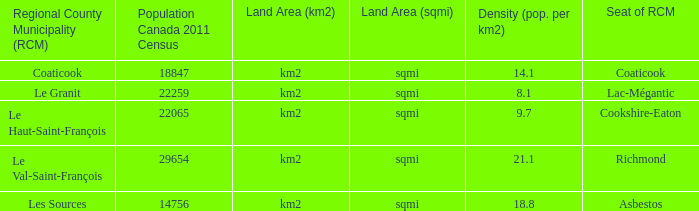What is the land coverage of the rcm that has a density of 2 Km2 (sqmi). 